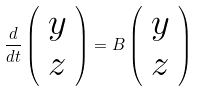Convert formula to latex. <formula><loc_0><loc_0><loc_500><loc_500>\frac { d } { d t } \left ( \begin{array} { c } y \\ z \end{array} \right ) = B \left ( \begin{array} { c } y \\ z \end{array} \right )</formula> 